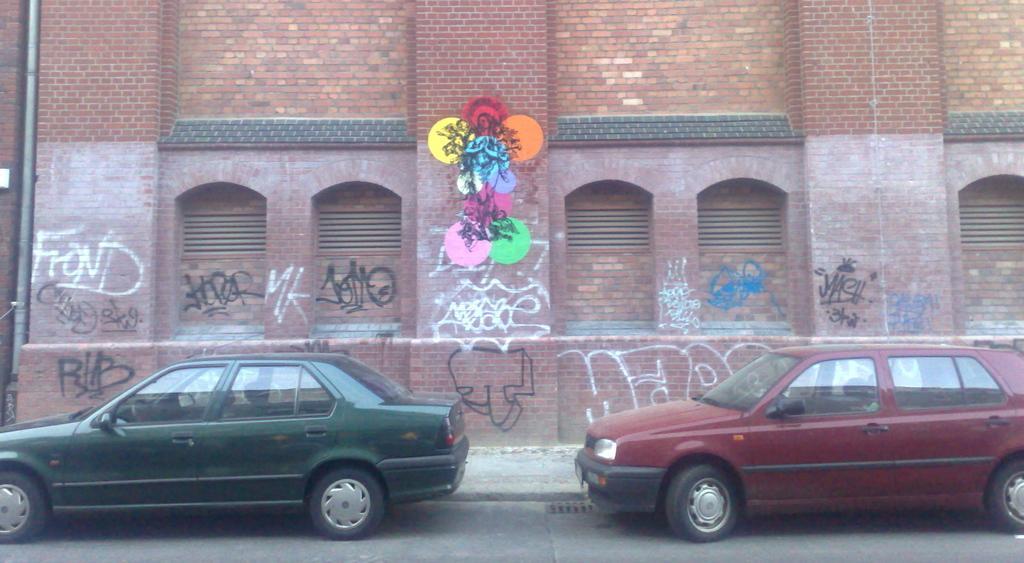In one or two sentences, can you explain what this image depicts? In this image we can see a building with windows, a pipe and some text on its wall. We can also see some cars on the ground. 